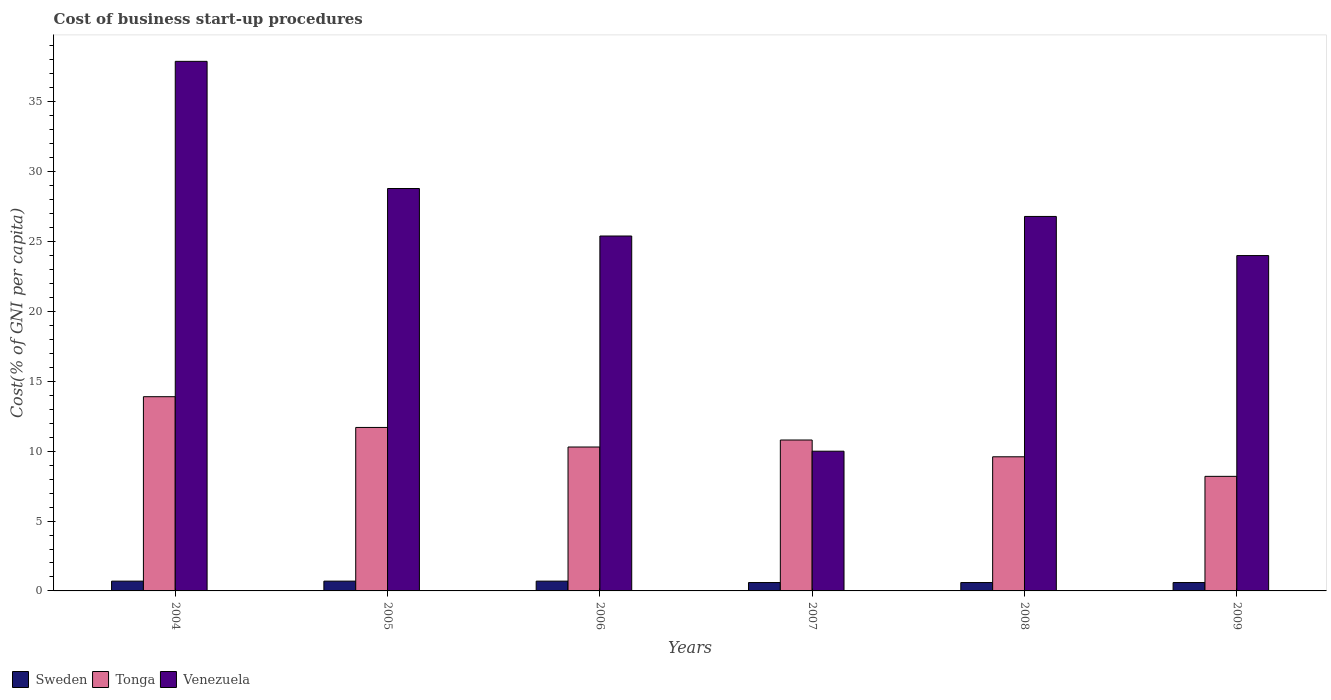How many different coloured bars are there?
Give a very brief answer. 3. Are the number of bars per tick equal to the number of legend labels?
Offer a terse response. Yes. Are the number of bars on each tick of the X-axis equal?
Ensure brevity in your answer.  Yes. Across all years, what is the maximum cost of business start-up procedures in Venezuela?
Offer a terse response. 37.9. In which year was the cost of business start-up procedures in Venezuela maximum?
Your answer should be very brief. 2004. What is the total cost of business start-up procedures in Sweden in the graph?
Provide a short and direct response. 3.9. What is the difference between the cost of business start-up procedures in Sweden in 2008 and the cost of business start-up procedures in Venezuela in 2007?
Give a very brief answer. -9.4. What is the average cost of business start-up procedures in Sweden per year?
Your response must be concise. 0.65. In the year 2008, what is the difference between the cost of business start-up procedures in Venezuela and cost of business start-up procedures in Tonga?
Your response must be concise. 17.2. In how many years, is the cost of business start-up procedures in Venezuela greater than 33 %?
Offer a very short reply. 1. What is the ratio of the cost of business start-up procedures in Venezuela in 2005 to that in 2007?
Your response must be concise. 2.88. Is the cost of business start-up procedures in Tonga in 2007 less than that in 2008?
Keep it short and to the point. No. What is the difference between the highest and the second highest cost of business start-up procedures in Tonga?
Offer a terse response. 2.2. What is the difference between the highest and the lowest cost of business start-up procedures in Tonga?
Provide a short and direct response. 5.7. What does the 2nd bar from the left in 2008 represents?
Offer a terse response. Tonga. What does the 2nd bar from the right in 2006 represents?
Offer a terse response. Tonga. Is it the case that in every year, the sum of the cost of business start-up procedures in Tonga and cost of business start-up procedures in Venezuela is greater than the cost of business start-up procedures in Sweden?
Your answer should be compact. Yes. Are all the bars in the graph horizontal?
Provide a short and direct response. No. How many years are there in the graph?
Your response must be concise. 6. What is the difference between two consecutive major ticks on the Y-axis?
Offer a very short reply. 5. Does the graph contain grids?
Make the answer very short. No. How many legend labels are there?
Your response must be concise. 3. How are the legend labels stacked?
Offer a very short reply. Horizontal. What is the title of the graph?
Your answer should be compact. Cost of business start-up procedures. Does "Mauritania" appear as one of the legend labels in the graph?
Make the answer very short. No. What is the label or title of the X-axis?
Offer a very short reply. Years. What is the label or title of the Y-axis?
Provide a short and direct response. Cost(% of GNI per capita). What is the Cost(% of GNI per capita) of Venezuela in 2004?
Your answer should be very brief. 37.9. What is the Cost(% of GNI per capita) in Sweden in 2005?
Offer a terse response. 0.7. What is the Cost(% of GNI per capita) in Tonga in 2005?
Ensure brevity in your answer.  11.7. What is the Cost(% of GNI per capita) of Venezuela in 2005?
Provide a succinct answer. 28.8. What is the Cost(% of GNI per capita) in Sweden in 2006?
Your answer should be compact. 0.7. What is the Cost(% of GNI per capita) of Venezuela in 2006?
Keep it short and to the point. 25.4. What is the Cost(% of GNI per capita) of Sweden in 2007?
Offer a terse response. 0.6. What is the Cost(% of GNI per capita) of Sweden in 2008?
Provide a succinct answer. 0.6. What is the Cost(% of GNI per capita) of Venezuela in 2008?
Provide a succinct answer. 26.8. What is the Cost(% of GNI per capita) of Sweden in 2009?
Your answer should be compact. 0.6. What is the Cost(% of GNI per capita) in Tonga in 2009?
Give a very brief answer. 8.2. What is the Cost(% of GNI per capita) in Venezuela in 2009?
Provide a short and direct response. 24. Across all years, what is the maximum Cost(% of GNI per capita) of Sweden?
Give a very brief answer. 0.7. Across all years, what is the maximum Cost(% of GNI per capita) in Venezuela?
Provide a short and direct response. 37.9. Across all years, what is the minimum Cost(% of GNI per capita) in Venezuela?
Your answer should be compact. 10. What is the total Cost(% of GNI per capita) in Sweden in the graph?
Give a very brief answer. 3.9. What is the total Cost(% of GNI per capita) in Tonga in the graph?
Your answer should be compact. 64.5. What is the total Cost(% of GNI per capita) of Venezuela in the graph?
Make the answer very short. 152.9. What is the difference between the Cost(% of GNI per capita) of Sweden in 2004 and that in 2005?
Offer a terse response. 0. What is the difference between the Cost(% of GNI per capita) of Tonga in 2004 and that in 2005?
Give a very brief answer. 2.2. What is the difference between the Cost(% of GNI per capita) in Venezuela in 2004 and that in 2005?
Provide a succinct answer. 9.1. What is the difference between the Cost(% of GNI per capita) in Tonga in 2004 and that in 2006?
Give a very brief answer. 3.6. What is the difference between the Cost(% of GNI per capita) of Venezuela in 2004 and that in 2006?
Provide a succinct answer. 12.5. What is the difference between the Cost(% of GNI per capita) in Sweden in 2004 and that in 2007?
Your answer should be compact. 0.1. What is the difference between the Cost(% of GNI per capita) of Venezuela in 2004 and that in 2007?
Your answer should be very brief. 27.9. What is the difference between the Cost(% of GNI per capita) in Venezuela in 2004 and that in 2009?
Your answer should be very brief. 13.9. What is the difference between the Cost(% of GNI per capita) in Sweden in 2005 and that in 2006?
Provide a short and direct response. 0. What is the difference between the Cost(% of GNI per capita) of Tonga in 2005 and that in 2006?
Provide a succinct answer. 1.4. What is the difference between the Cost(% of GNI per capita) in Tonga in 2005 and that in 2007?
Your answer should be compact. 0.9. What is the difference between the Cost(% of GNI per capita) of Tonga in 2005 and that in 2009?
Ensure brevity in your answer.  3.5. What is the difference between the Cost(% of GNI per capita) in Venezuela in 2005 and that in 2009?
Your answer should be compact. 4.8. What is the difference between the Cost(% of GNI per capita) in Tonga in 2006 and that in 2007?
Provide a short and direct response. -0.5. What is the difference between the Cost(% of GNI per capita) of Venezuela in 2006 and that in 2007?
Offer a terse response. 15.4. What is the difference between the Cost(% of GNI per capita) in Tonga in 2006 and that in 2008?
Make the answer very short. 0.7. What is the difference between the Cost(% of GNI per capita) of Venezuela in 2006 and that in 2008?
Keep it short and to the point. -1.4. What is the difference between the Cost(% of GNI per capita) in Sweden in 2006 and that in 2009?
Ensure brevity in your answer.  0.1. What is the difference between the Cost(% of GNI per capita) of Venezuela in 2006 and that in 2009?
Offer a terse response. 1.4. What is the difference between the Cost(% of GNI per capita) in Tonga in 2007 and that in 2008?
Give a very brief answer. 1.2. What is the difference between the Cost(% of GNI per capita) of Venezuela in 2007 and that in 2008?
Offer a very short reply. -16.8. What is the difference between the Cost(% of GNI per capita) in Tonga in 2007 and that in 2009?
Give a very brief answer. 2.6. What is the difference between the Cost(% of GNI per capita) in Sweden in 2008 and that in 2009?
Ensure brevity in your answer.  0. What is the difference between the Cost(% of GNI per capita) in Sweden in 2004 and the Cost(% of GNI per capita) in Venezuela in 2005?
Offer a terse response. -28.1. What is the difference between the Cost(% of GNI per capita) in Tonga in 2004 and the Cost(% of GNI per capita) in Venezuela in 2005?
Your answer should be very brief. -14.9. What is the difference between the Cost(% of GNI per capita) of Sweden in 2004 and the Cost(% of GNI per capita) of Venezuela in 2006?
Provide a short and direct response. -24.7. What is the difference between the Cost(% of GNI per capita) in Tonga in 2004 and the Cost(% of GNI per capita) in Venezuela in 2006?
Your response must be concise. -11.5. What is the difference between the Cost(% of GNI per capita) of Sweden in 2004 and the Cost(% of GNI per capita) of Venezuela in 2007?
Your response must be concise. -9.3. What is the difference between the Cost(% of GNI per capita) in Sweden in 2004 and the Cost(% of GNI per capita) in Tonga in 2008?
Keep it short and to the point. -8.9. What is the difference between the Cost(% of GNI per capita) in Sweden in 2004 and the Cost(% of GNI per capita) in Venezuela in 2008?
Make the answer very short. -26.1. What is the difference between the Cost(% of GNI per capita) of Tonga in 2004 and the Cost(% of GNI per capita) of Venezuela in 2008?
Offer a terse response. -12.9. What is the difference between the Cost(% of GNI per capita) of Sweden in 2004 and the Cost(% of GNI per capita) of Tonga in 2009?
Offer a very short reply. -7.5. What is the difference between the Cost(% of GNI per capita) in Sweden in 2004 and the Cost(% of GNI per capita) in Venezuela in 2009?
Your answer should be very brief. -23.3. What is the difference between the Cost(% of GNI per capita) in Sweden in 2005 and the Cost(% of GNI per capita) in Tonga in 2006?
Make the answer very short. -9.6. What is the difference between the Cost(% of GNI per capita) of Sweden in 2005 and the Cost(% of GNI per capita) of Venezuela in 2006?
Offer a very short reply. -24.7. What is the difference between the Cost(% of GNI per capita) in Tonga in 2005 and the Cost(% of GNI per capita) in Venezuela in 2006?
Ensure brevity in your answer.  -13.7. What is the difference between the Cost(% of GNI per capita) of Tonga in 2005 and the Cost(% of GNI per capita) of Venezuela in 2007?
Your answer should be very brief. 1.7. What is the difference between the Cost(% of GNI per capita) in Sweden in 2005 and the Cost(% of GNI per capita) in Tonga in 2008?
Offer a very short reply. -8.9. What is the difference between the Cost(% of GNI per capita) in Sweden in 2005 and the Cost(% of GNI per capita) in Venezuela in 2008?
Ensure brevity in your answer.  -26.1. What is the difference between the Cost(% of GNI per capita) of Tonga in 2005 and the Cost(% of GNI per capita) of Venezuela in 2008?
Provide a short and direct response. -15.1. What is the difference between the Cost(% of GNI per capita) in Sweden in 2005 and the Cost(% of GNI per capita) in Venezuela in 2009?
Your answer should be very brief. -23.3. What is the difference between the Cost(% of GNI per capita) in Tonga in 2006 and the Cost(% of GNI per capita) in Venezuela in 2007?
Provide a succinct answer. 0.3. What is the difference between the Cost(% of GNI per capita) in Sweden in 2006 and the Cost(% of GNI per capita) in Venezuela in 2008?
Your response must be concise. -26.1. What is the difference between the Cost(% of GNI per capita) of Tonga in 2006 and the Cost(% of GNI per capita) of Venezuela in 2008?
Keep it short and to the point. -16.5. What is the difference between the Cost(% of GNI per capita) in Sweden in 2006 and the Cost(% of GNI per capita) in Tonga in 2009?
Provide a succinct answer. -7.5. What is the difference between the Cost(% of GNI per capita) of Sweden in 2006 and the Cost(% of GNI per capita) of Venezuela in 2009?
Make the answer very short. -23.3. What is the difference between the Cost(% of GNI per capita) of Tonga in 2006 and the Cost(% of GNI per capita) of Venezuela in 2009?
Keep it short and to the point. -13.7. What is the difference between the Cost(% of GNI per capita) in Sweden in 2007 and the Cost(% of GNI per capita) in Venezuela in 2008?
Keep it short and to the point. -26.2. What is the difference between the Cost(% of GNI per capita) of Tonga in 2007 and the Cost(% of GNI per capita) of Venezuela in 2008?
Offer a terse response. -16. What is the difference between the Cost(% of GNI per capita) of Sweden in 2007 and the Cost(% of GNI per capita) of Tonga in 2009?
Provide a succinct answer. -7.6. What is the difference between the Cost(% of GNI per capita) in Sweden in 2007 and the Cost(% of GNI per capita) in Venezuela in 2009?
Offer a very short reply. -23.4. What is the difference between the Cost(% of GNI per capita) in Sweden in 2008 and the Cost(% of GNI per capita) in Tonga in 2009?
Offer a very short reply. -7.6. What is the difference between the Cost(% of GNI per capita) of Sweden in 2008 and the Cost(% of GNI per capita) of Venezuela in 2009?
Ensure brevity in your answer.  -23.4. What is the difference between the Cost(% of GNI per capita) in Tonga in 2008 and the Cost(% of GNI per capita) in Venezuela in 2009?
Provide a short and direct response. -14.4. What is the average Cost(% of GNI per capita) of Sweden per year?
Offer a terse response. 0.65. What is the average Cost(% of GNI per capita) in Tonga per year?
Provide a succinct answer. 10.75. What is the average Cost(% of GNI per capita) in Venezuela per year?
Your response must be concise. 25.48. In the year 2004, what is the difference between the Cost(% of GNI per capita) in Sweden and Cost(% of GNI per capita) in Tonga?
Give a very brief answer. -13.2. In the year 2004, what is the difference between the Cost(% of GNI per capita) of Sweden and Cost(% of GNI per capita) of Venezuela?
Offer a very short reply. -37.2. In the year 2005, what is the difference between the Cost(% of GNI per capita) of Sweden and Cost(% of GNI per capita) of Tonga?
Offer a very short reply. -11. In the year 2005, what is the difference between the Cost(% of GNI per capita) in Sweden and Cost(% of GNI per capita) in Venezuela?
Offer a very short reply. -28.1. In the year 2005, what is the difference between the Cost(% of GNI per capita) in Tonga and Cost(% of GNI per capita) in Venezuela?
Provide a succinct answer. -17.1. In the year 2006, what is the difference between the Cost(% of GNI per capita) of Sweden and Cost(% of GNI per capita) of Tonga?
Make the answer very short. -9.6. In the year 2006, what is the difference between the Cost(% of GNI per capita) of Sweden and Cost(% of GNI per capita) of Venezuela?
Provide a succinct answer. -24.7. In the year 2006, what is the difference between the Cost(% of GNI per capita) of Tonga and Cost(% of GNI per capita) of Venezuela?
Your response must be concise. -15.1. In the year 2007, what is the difference between the Cost(% of GNI per capita) in Sweden and Cost(% of GNI per capita) in Tonga?
Ensure brevity in your answer.  -10.2. In the year 2008, what is the difference between the Cost(% of GNI per capita) of Sweden and Cost(% of GNI per capita) of Tonga?
Offer a very short reply. -9. In the year 2008, what is the difference between the Cost(% of GNI per capita) of Sweden and Cost(% of GNI per capita) of Venezuela?
Your answer should be very brief. -26.2. In the year 2008, what is the difference between the Cost(% of GNI per capita) in Tonga and Cost(% of GNI per capita) in Venezuela?
Keep it short and to the point. -17.2. In the year 2009, what is the difference between the Cost(% of GNI per capita) in Sweden and Cost(% of GNI per capita) in Tonga?
Keep it short and to the point. -7.6. In the year 2009, what is the difference between the Cost(% of GNI per capita) of Sweden and Cost(% of GNI per capita) of Venezuela?
Ensure brevity in your answer.  -23.4. In the year 2009, what is the difference between the Cost(% of GNI per capita) of Tonga and Cost(% of GNI per capita) of Venezuela?
Ensure brevity in your answer.  -15.8. What is the ratio of the Cost(% of GNI per capita) of Sweden in 2004 to that in 2005?
Make the answer very short. 1. What is the ratio of the Cost(% of GNI per capita) of Tonga in 2004 to that in 2005?
Keep it short and to the point. 1.19. What is the ratio of the Cost(% of GNI per capita) in Venezuela in 2004 to that in 2005?
Your answer should be compact. 1.32. What is the ratio of the Cost(% of GNI per capita) of Sweden in 2004 to that in 2006?
Your answer should be compact. 1. What is the ratio of the Cost(% of GNI per capita) of Tonga in 2004 to that in 2006?
Provide a short and direct response. 1.35. What is the ratio of the Cost(% of GNI per capita) of Venezuela in 2004 to that in 2006?
Your response must be concise. 1.49. What is the ratio of the Cost(% of GNI per capita) in Tonga in 2004 to that in 2007?
Your answer should be very brief. 1.29. What is the ratio of the Cost(% of GNI per capita) of Venezuela in 2004 to that in 2007?
Ensure brevity in your answer.  3.79. What is the ratio of the Cost(% of GNI per capita) of Tonga in 2004 to that in 2008?
Make the answer very short. 1.45. What is the ratio of the Cost(% of GNI per capita) in Venezuela in 2004 to that in 2008?
Your response must be concise. 1.41. What is the ratio of the Cost(% of GNI per capita) in Tonga in 2004 to that in 2009?
Give a very brief answer. 1.7. What is the ratio of the Cost(% of GNI per capita) in Venezuela in 2004 to that in 2009?
Provide a succinct answer. 1.58. What is the ratio of the Cost(% of GNI per capita) in Tonga in 2005 to that in 2006?
Provide a succinct answer. 1.14. What is the ratio of the Cost(% of GNI per capita) of Venezuela in 2005 to that in 2006?
Your response must be concise. 1.13. What is the ratio of the Cost(% of GNI per capita) in Tonga in 2005 to that in 2007?
Your response must be concise. 1.08. What is the ratio of the Cost(% of GNI per capita) in Venezuela in 2005 to that in 2007?
Your answer should be very brief. 2.88. What is the ratio of the Cost(% of GNI per capita) in Tonga in 2005 to that in 2008?
Offer a very short reply. 1.22. What is the ratio of the Cost(% of GNI per capita) of Venezuela in 2005 to that in 2008?
Ensure brevity in your answer.  1.07. What is the ratio of the Cost(% of GNI per capita) in Sweden in 2005 to that in 2009?
Your answer should be compact. 1.17. What is the ratio of the Cost(% of GNI per capita) in Tonga in 2005 to that in 2009?
Your answer should be very brief. 1.43. What is the ratio of the Cost(% of GNI per capita) in Sweden in 2006 to that in 2007?
Your answer should be very brief. 1.17. What is the ratio of the Cost(% of GNI per capita) in Tonga in 2006 to that in 2007?
Your answer should be compact. 0.95. What is the ratio of the Cost(% of GNI per capita) in Venezuela in 2006 to that in 2007?
Your answer should be compact. 2.54. What is the ratio of the Cost(% of GNI per capita) in Sweden in 2006 to that in 2008?
Provide a short and direct response. 1.17. What is the ratio of the Cost(% of GNI per capita) in Tonga in 2006 to that in 2008?
Your answer should be very brief. 1.07. What is the ratio of the Cost(% of GNI per capita) in Venezuela in 2006 to that in 2008?
Make the answer very short. 0.95. What is the ratio of the Cost(% of GNI per capita) of Sweden in 2006 to that in 2009?
Offer a very short reply. 1.17. What is the ratio of the Cost(% of GNI per capita) of Tonga in 2006 to that in 2009?
Make the answer very short. 1.26. What is the ratio of the Cost(% of GNI per capita) of Venezuela in 2006 to that in 2009?
Provide a succinct answer. 1.06. What is the ratio of the Cost(% of GNI per capita) of Tonga in 2007 to that in 2008?
Ensure brevity in your answer.  1.12. What is the ratio of the Cost(% of GNI per capita) of Venezuela in 2007 to that in 2008?
Make the answer very short. 0.37. What is the ratio of the Cost(% of GNI per capita) of Sweden in 2007 to that in 2009?
Keep it short and to the point. 1. What is the ratio of the Cost(% of GNI per capita) in Tonga in 2007 to that in 2009?
Your response must be concise. 1.32. What is the ratio of the Cost(% of GNI per capita) in Venezuela in 2007 to that in 2009?
Offer a very short reply. 0.42. What is the ratio of the Cost(% of GNI per capita) in Sweden in 2008 to that in 2009?
Keep it short and to the point. 1. What is the ratio of the Cost(% of GNI per capita) of Tonga in 2008 to that in 2009?
Your answer should be very brief. 1.17. What is the ratio of the Cost(% of GNI per capita) of Venezuela in 2008 to that in 2009?
Ensure brevity in your answer.  1.12. What is the difference between the highest and the second highest Cost(% of GNI per capita) in Tonga?
Offer a terse response. 2.2. What is the difference between the highest and the lowest Cost(% of GNI per capita) of Venezuela?
Give a very brief answer. 27.9. 